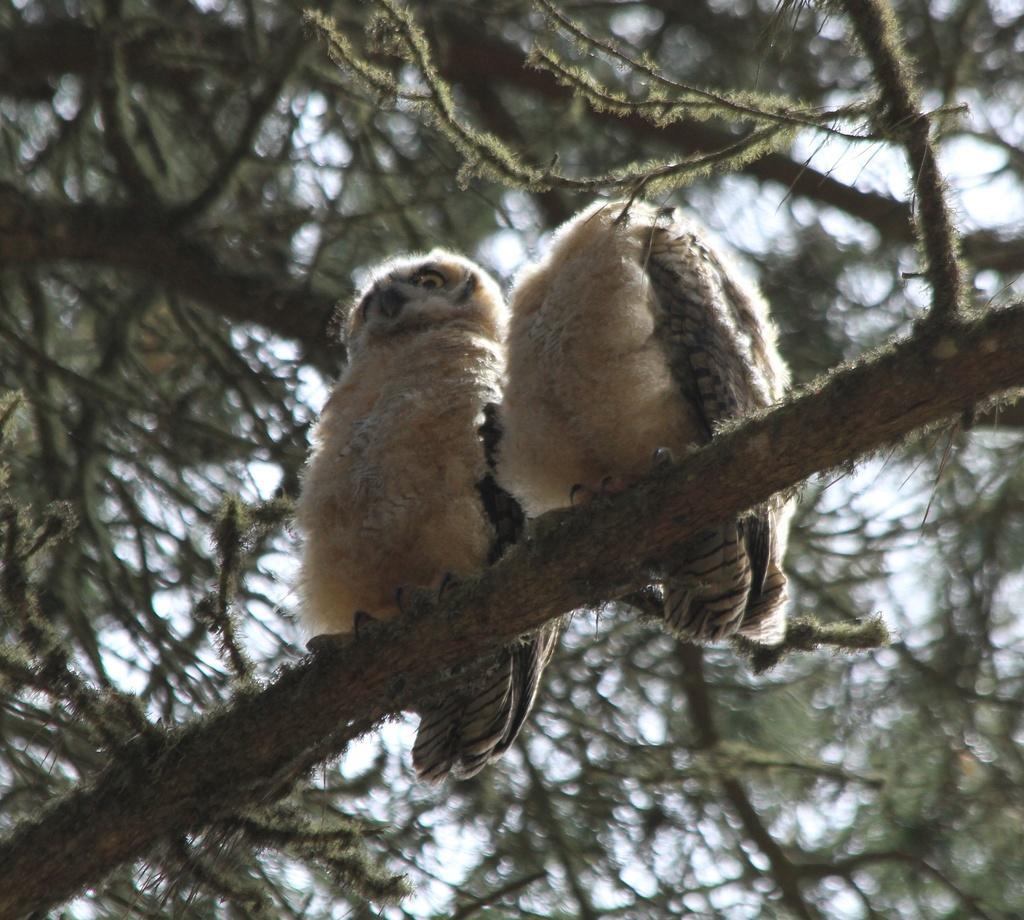How would you summarize this image in a sentence or two? In this image we can see two birds on the branch of a tree. On the backside we can see the sky. 